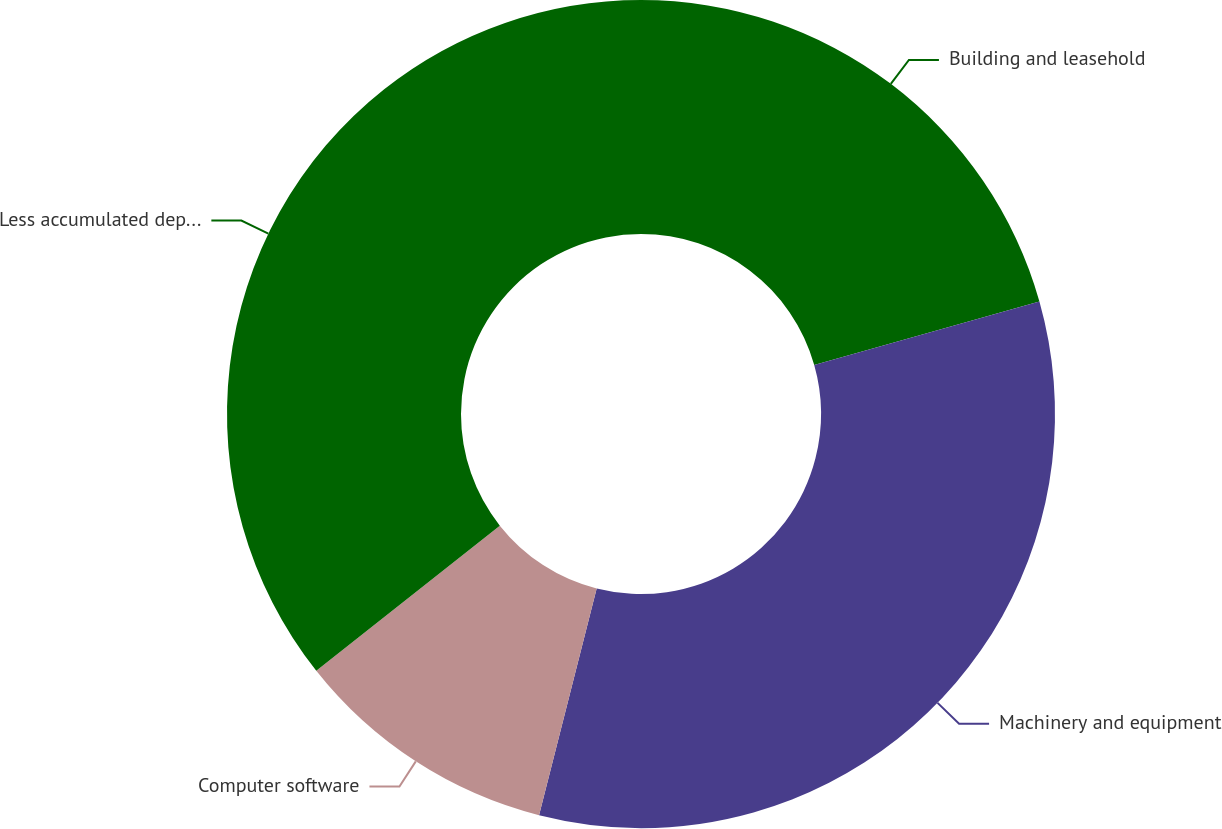Convert chart to OTSL. <chart><loc_0><loc_0><loc_500><loc_500><pie_chart><fcel>Building and leasehold<fcel>Machinery and equipment<fcel>Computer software<fcel>Less accumulated depreciation<nl><fcel>20.62%<fcel>33.34%<fcel>10.39%<fcel>35.65%<nl></chart> 